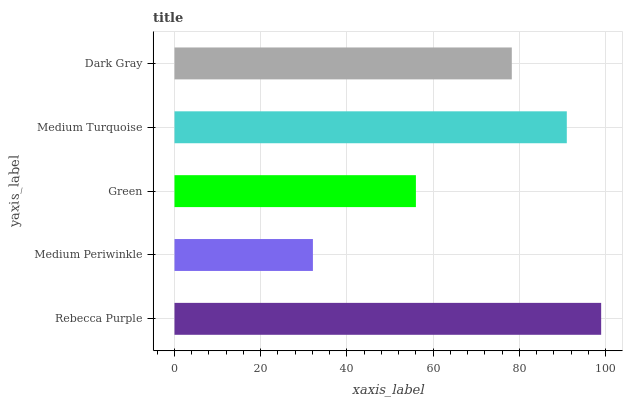Is Medium Periwinkle the minimum?
Answer yes or no. Yes. Is Rebecca Purple the maximum?
Answer yes or no. Yes. Is Green the minimum?
Answer yes or no. No. Is Green the maximum?
Answer yes or no. No. Is Green greater than Medium Periwinkle?
Answer yes or no. Yes. Is Medium Periwinkle less than Green?
Answer yes or no. Yes. Is Medium Periwinkle greater than Green?
Answer yes or no. No. Is Green less than Medium Periwinkle?
Answer yes or no. No. Is Dark Gray the high median?
Answer yes or no. Yes. Is Dark Gray the low median?
Answer yes or no. Yes. Is Green the high median?
Answer yes or no. No. Is Medium Periwinkle the low median?
Answer yes or no. No. 